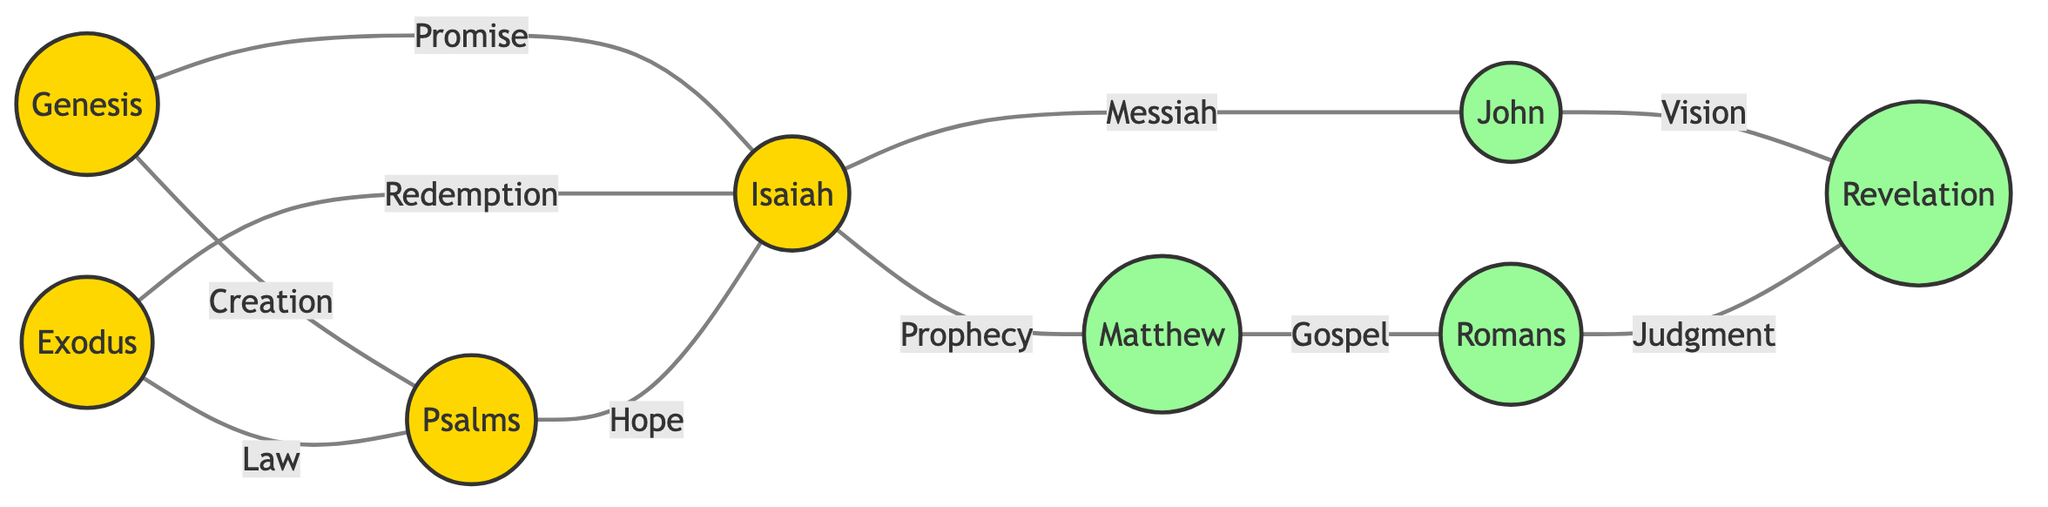What is the total number of nodes in the diagram? The diagram contains a list of nodes representing different sections of the Bible. By counting each node listed, we find there are eight nodes: Genesis, Exodus, Psalms, Isaiah, Matthew, John, Romans, and Revelation.
Answer: 8 Which book of the Bible is connected to both Exodus and Isaiah? By examining the edges connected to the node "Exodus", we see it connects to "Psalms" and "Isaiah". Since "Isaiah" is also connected to "Exodus" via the edge labeled "Redemption", it confirms the connection to these books.
Answer: Psalms What theme connects Isaiah to both Matthew and John? Looking at the edges from "Isaiah", we observe that it connects to both "Matthew" and "John" through the edges labeled "Prophecy" and "Messiah", respectively. This indicates the theme of prophecy reflected in both New Testament books.
Answer: Prophecy Which section of the Bible comes after the book of John in the diagram? In the diagram, "John" is connected to "Revelation" through the edge labeled "Vision". Thus, "Revelation" follows "John" in the diagram flow.
Answer: Revelation How many edges are there between Old Testament books and New Testament books? By reviewing the edges, we find connections between "Genesis" (Old Testament), "Exodus" (Old Testament), and "Isaiah" (Old Testament) to "Matthew" and "John" (New Testament) as well as "Romans" and "Revelation" (New Testament). The total count of edges connecting Old to New Testament books is five: Genesis to Psalms, Genesis to Isaiah, Exodus to Psalms, Isaiah to Matthew, and Isaiah to John.
Answer: 5 What is the relationship between Romans and Revelation? In the diagram, "Romans" is connected to "Revelation" through the edge labeled "Judgment". This indicates a thematic connection concerning the final judgment.
Answer: Judgment Which book signifies the theme of creation in the diagram? The node "Genesis" is labeled and connected to "Psalms" through the edge labeled "Creation". This shows that the theme of creation is represented by the book of Genesis.
Answer: Genesis Which two themes link Psalms and Isaiah? There are two edges connecting "Psalms" and "Isaiah": the edge labeled "Hope" and the one labeled "Law" (from Exodus to Psalms and Exodus to Isaiah). Thus, both themes "Hope" and "Law" link these two books together.
Answer: Hope and Law 